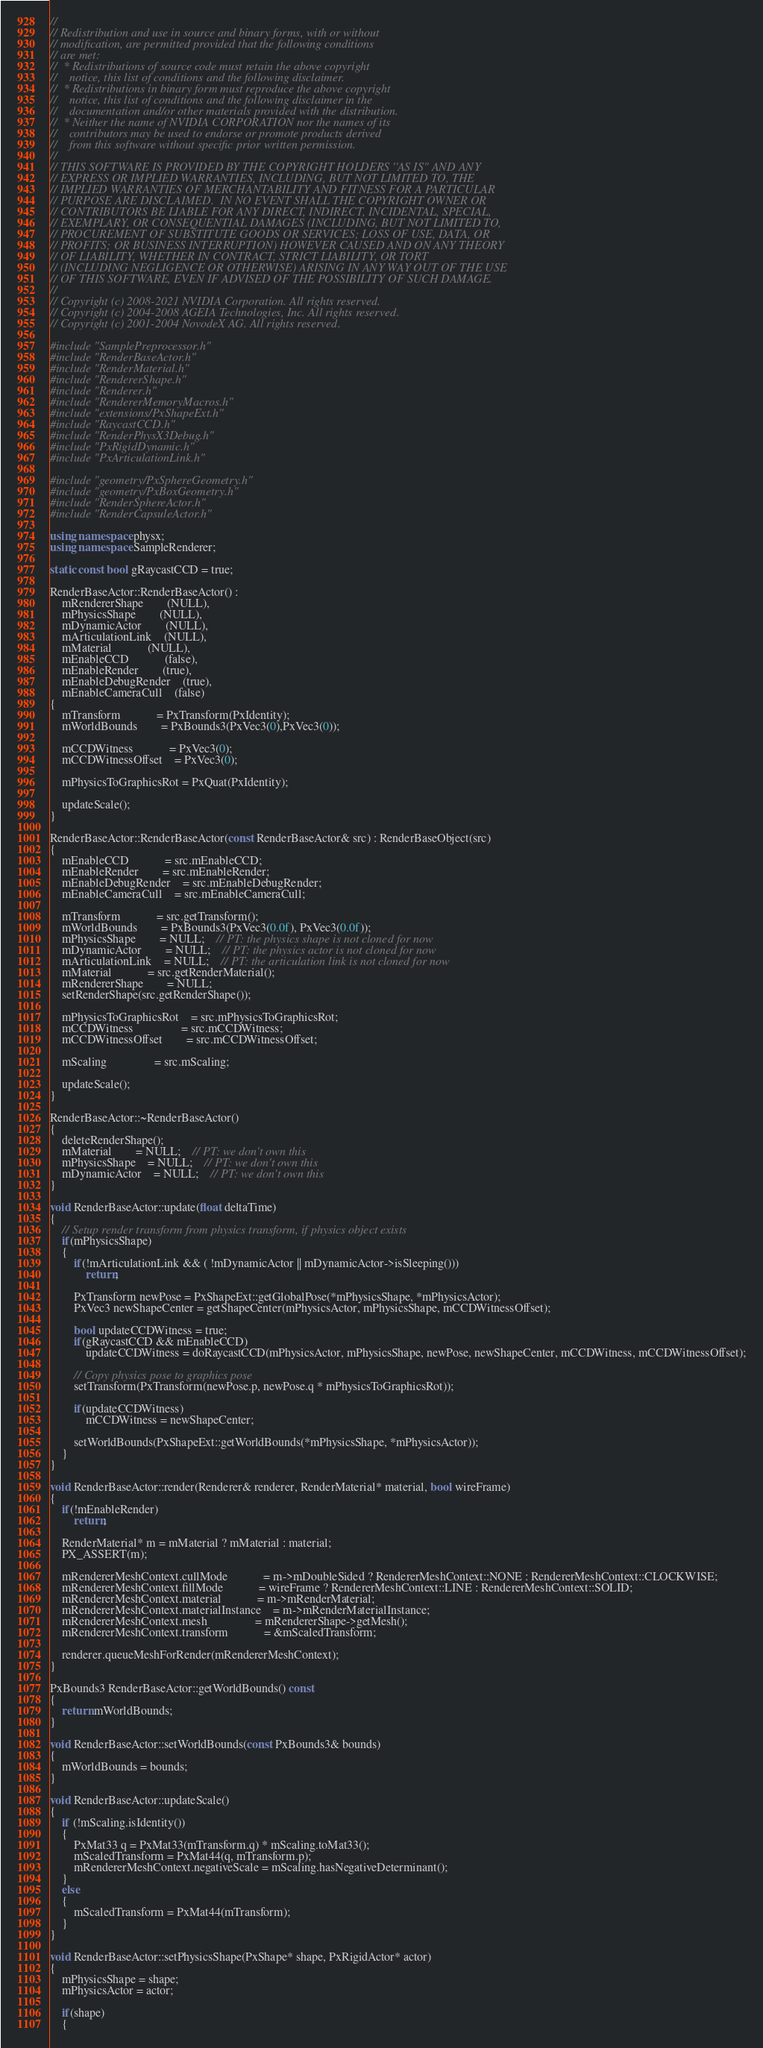<code> <loc_0><loc_0><loc_500><loc_500><_C++_>//
// Redistribution and use in source and binary forms, with or without
// modification, are permitted provided that the following conditions
// are met:
//  * Redistributions of source code must retain the above copyright
//    notice, this list of conditions and the following disclaimer.
//  * Redistributions in binary form must reproduce the above copyright
//    notice, this list of conditions and the following disclaimer in the
//    documentation and/or other materials provided with the distribution.
//  * Neither the name of NVIDIA CORPORATION nor the names of its
//    contributors may be used to endorse or promote products derived
//    from this software without specific prior written permission.
//
// THIS SOFTWARE IS PROVIDED BY THE COPYRIGHT HOLDERS ''AS IS'' AND ANY
// EXPRESS OR IMPLIED WARRANTIES, INCLUDING, BUT NOT LIMITED TO, THE
// IMPLIED WARRANTIES OF MERCHANTABILITY AND FITNESS FOR A PARTICULAR
// PURPOSE ARE DISCLAIMED.  IN NO EVENT SHALL THE COPYRIGHT OWNER OR
// CONTRIBUTORS BE LIABLE FOR ANY DIRECT, INDIRECT, INCIDENTAL, SPECIAL,
// EXEMPLARY, OR CONSEQUENTIAL DAMAGES (INCLUDING, BUT NOT LIMITED TO,
// PROCUREMENT OF SUBSTITUTE GOODS OR SERVICES; LOSS OF USE, DATA, OR
// PROFITS; OR BUSINESS INTERRUPTION) HOWEVER CAUSED AND ON ANY THEORY
// OF LIABILITY, WHETHER IN CONTRACT, STRICT LIABILITY, OR TORT
// (INCLUDING NEGLIGENCE OR OTHERWISE) ARISING IN ANY WAY OUT OF THE USE
// OF THIS SOFTWARE, EVEN IF ADVISED OF THE POSSIBILITY OF SUCH DAMAGE.
//
// Copyright (c) 2008-2021 NVIDIA Corporation. All rights reserved.
// Copyright (c) 2004-2008 AGEIA Technologies, Inc. All rights reserved.
// Copyright (c) 2001-2004 NovodeX AG. All rights reserved.  

#include "SamplePreprocessor.h"
#include "RenderBaseActor.h"
#include "RenderMaterial.h"
#include "RendererShape.h"
#include "Renderer.h"
#include "RendererMemoryMacros.h"
#include "extensions/PxShapeExt.h"
#include "RaycastCCD.h"
#include "RenderPhysX3Debug.h"
#include "PxRigidDynamic.h"
#include "PxArticulationLink.h"

#include "geometry/PxSphereGeometry.h"
#include "geometry/PxBoxGeometry.h"
#include "RenderSphereActor.h"
#include "RenderCapsuleActor.h"

using namespace physx;
using namespace SampleRenderer;

static const bool gRaycastCCD = true;

RenderBaseActor::RenderBaseActor() :
	mRendererShape		(NULL),
	mPhysicsShape		(NULL),
	mDynamicActor		(NULL),
	mArticulationLink	(NULL),
	mMaterial			(NULL),
	mEnableCCD			(false),
	mEnableRender		(true),
	mEnableDebugRender	(true),
	mEnableCameraCull	(false)
{
	mTransform			= PxTransform(PxIdentity);
	mWorldBounds		= PxBounds3(PxVec3(0),PxVec3(0));

	mCCDWitness			= PxVec3(0);
	mCCDWitnessOffset	= PxVec3(0);

	mPhysicsToGraphicsRot = PxQuat(PxIdentity);

	updateScale();
}

RenderBaseActor::RenderBaseActor(const RenderBaseActor& src) : RenderBaseObject(src)
{
	mEnableCCD			= src.mEnableCCD;
	mEnableRender		= src.mEnableRender;
	mEnableDebugRender	= src.mEnableDebugRender;
	mEnableCameraCull	= src.mEnableCameraCull;

	mTransform			= src.getTransform();
	mWorldBounds		= PxBounds3(PxVec3(0.0f), PxVec3(0.0f));
	mPhysicsShape		= NULL;	// PT: the physics shape is not cloned for now
	mDynamicActor		= NULL;	// PT: the physics actor is not cloned for now
	mArticulationLink	= NULL;	// PT: the articulation link is not cloned for now
	mMaterial			= src.getRenderMaterial();
	mRendererShape		= NULL;
	setRenderShape(src.getRenderShape());

	mPhysicsToGraphicsRot	= src.mPhysicsToGraphicsRot;
	mCCDWitness				= src.mCCDWitness;
	mCCDWitnessOffset		= src.mCCDWitnessOffset;

	mScaling				= src.mScaling;

	updateScale();
}

RenderBaseActor::~RenderBaseActor()
{
	deleteRenderShape();
	mMaterial		= NULL;	// PT: we don't own this
	mPhysicsShape	= NULL;	// PT: we don't own this
	mDynamicActor	= NULL;	// PT: we don't own this
}

void RenderBaseActor::update(float deltaTime)
{
	// Setup render transform from physics transform, if physics object exists
	if(mPhysicsShape)
	{
		if(!mArticulationLink && ( !mDynamicActor || mDynamicActor->isSleeping()))
			return;

		PxTransform newPose = PxShapeExt::getGlobalPose(*mPhysicsShape, *mPhysicsActor);
		PxVec3 newShapeCenter = getShapeCenter(mPhysicsActor, mPhysicsShape, mCCDWitnessOffset);

		bool updateCCDWitness = true;
		if(gRaycastCCD && mEnableCCD)
			updateCCDWitness = doRaycastCCD(mPhysicsActor, mPhysicsShape, newPose, newShapeCenter, mCCDWitness, mCCDWitnessOffset);

		// Copy physics pose to graphics pose
		setTransform(PxTransform(newPose.p, newPose.q * mPhysicsToGraphicsRot));

		if(updateCCDWitness)
			mCCDWitness = newShapeCenter;
		
		setWorldBounds(PxShapeExt::getWorldBounds(*mPhysicsShape, *mPhysicsActor));
	}
}

void RenderBaseActor::render(Renderer& renderer, RenderMaterial* material, bool wireFrame)
{
	if(!mEnableRender)
		return;

	RenderMaterial* m = mMaterial ? mMaterial : material;
	PX_ASSERT(m);

	mRendererMeshContext.cullMode			= m->mDoubleSided ? RendererMeshContext::NONE : RendererMeshContext::CLOCKWISE;
	mRendererMeshContext.fillMode			= wireFrame ? RendererMeshContext::LINE : RendererMeshContext::SOLID;
	mRendererMeshContext.material			= m->mRenderMaterial;
	mRendererMeshContext.materialInstance	= m->mRenderMaterialInstance;
	mRendererMeshContext.mesh				= mRendererShape->getMesh();
	mRendererMeshContext.transform			= &mScaledTransform;

	renderer.queueMeshForRender(mRendererMeshContext);
}

PxBounds3 RenderBaseActor::getWorldBounds() const
{
	return mWorldBounds;
}

void RenderBaseActor::setWorldBounds(const PxBounds3& bounds)
{
	mWorldBounds = bounds;
}

void RenderBaseActor::updateScale()
{
	if (!mScaling.isIdentity())
	{
		PxMat33 q = PxMat33(mTransform.q) * mScaling.toMat33();
		mScaledTransform = PxMat44(q, mTransform.p);
		mRendererMeshContext.negativeScale = mScaling.hasNegativeDeterminant();
	}
	else
	{
		mScaledTransform = PxMat44(mTransform);
	}
}

void RenderBaseActor::setPhysicsShape(PxShape* shape, PxRigidActor* actor)
{
	mPhysicsShape = shape;
	mPhysicsActor = actor;

	if(shape)
	{</code> 